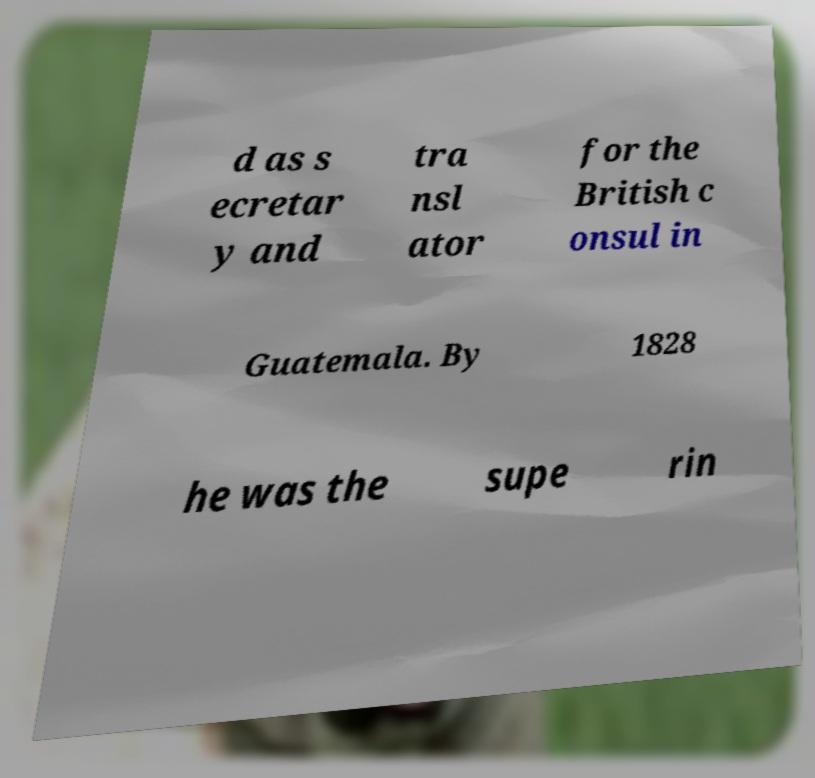Could you extract and type out the text from this image? d as s ecretar y and tra nsl ator for the British c onsul in Guatemala. By 1828 he was the supe rin 